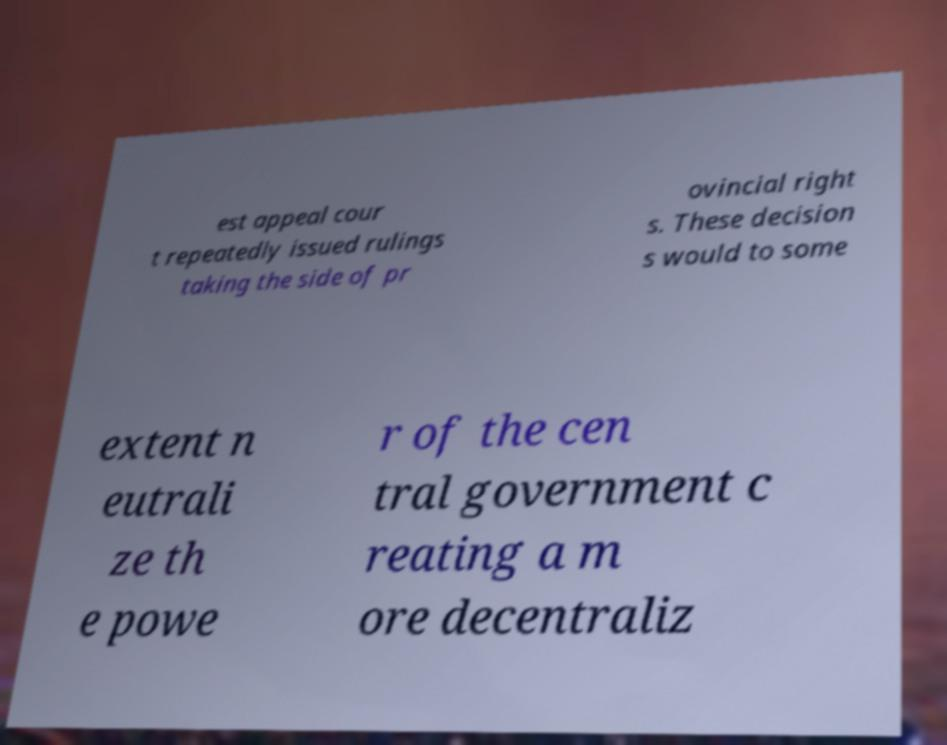Please read and relay the text visible in this image. What does it say? est appeal cour t repeatedly issued rulings taking the side of pr ovincial right s. These decision s would to some extent n eutrali ze th e powe r of the cen tral government c reating a m ore decentraliz 